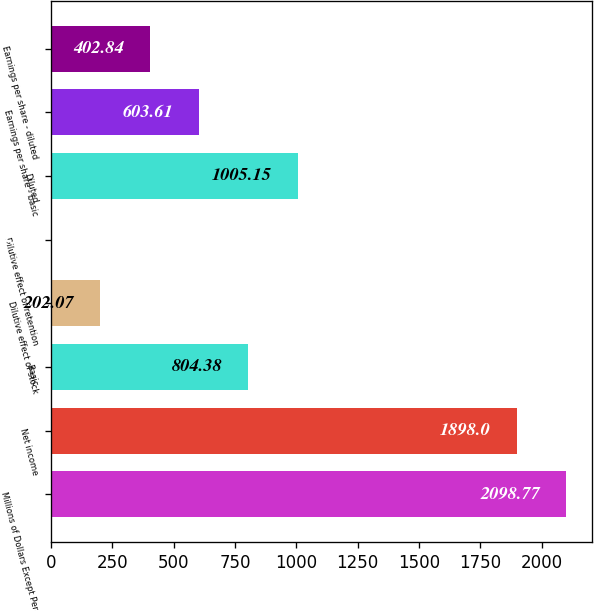Convert chart to OTSL. <chart><loc_0><loc_0><loc_500><loc_500><bar_chart><fcel>Millions of Dollars Except Per<fcel>Net income<fcel>Basic<fcel>Dilutive effect of stock<fcel>Dilutive effect of retention<fcel>Diluted<fcel>Earnings per share - basic<fcel>Earnings per share - diluted<nl><fcel>2098.77<fcel>1898<fcel>804.38<fcel>202.07<fcel>1.3<fcel>1005.15<fcel>603.61<fcel>402.84<nl></chart> 